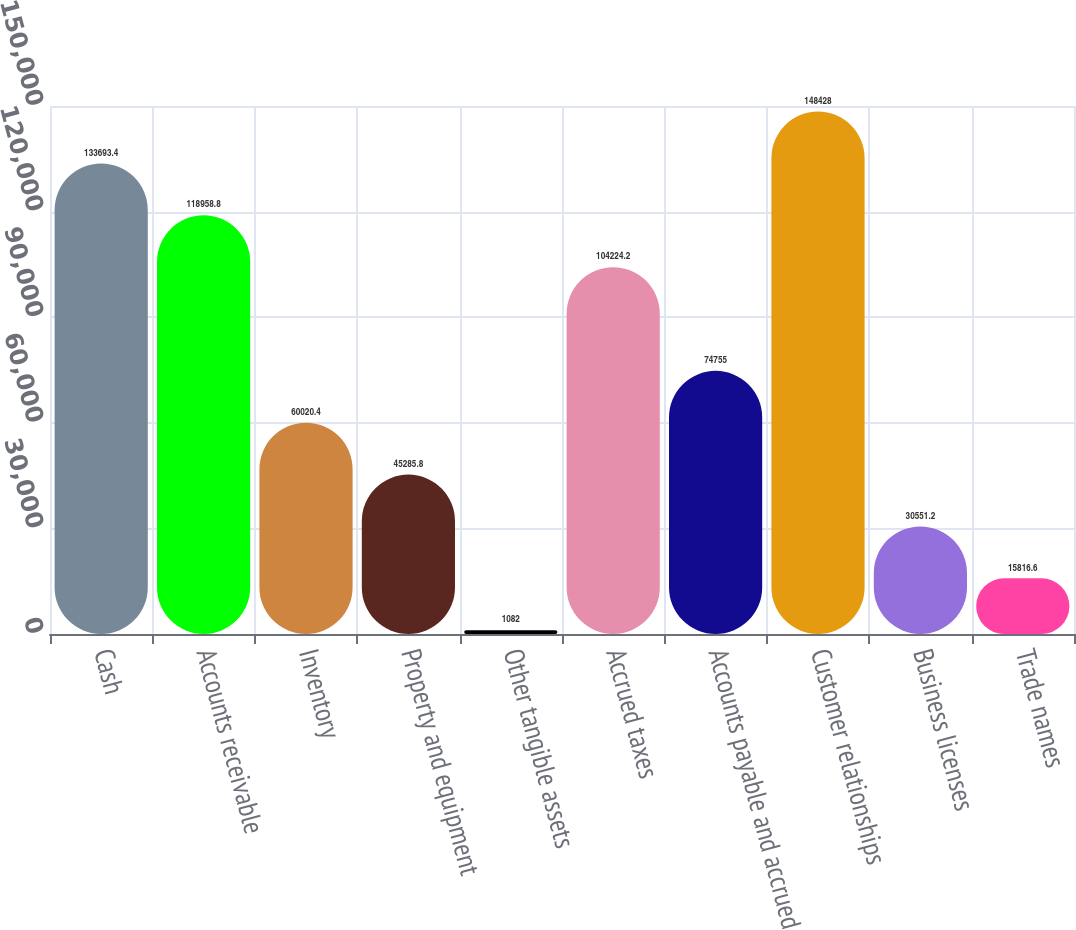Convert chart. <chart><loc_0><loc_0><loc_500><loc_500><bar_chart><fcel>Cash<fcel>Accounts receivable<fcel>Inventory<fcel>Property and equipment<fcel>Other tangible assets<fcel>Accrued taxes<fcel>Accounts payable and accrued<fcel>Customer relationships<fcel>Business licenses<fcel>Trade names<nl><fcel>133693<fcel>118959<fcel>60020.4<fcel>45285.8<fcel>1082<fcel>104224<fcel>74755<fcel>148428<fcel>30551.2<fcel>15816.6<nl></chart> 